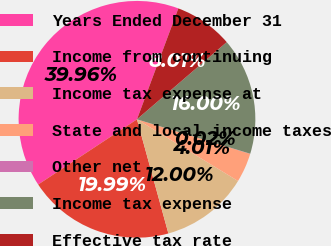Convert chart to OTSL. <chart><loc_0><loc_0><loc_500><loc_500><pie_chart><fcel>Years Ended December 31<fcel>Income from continuing<fcel>Income tax expense at<fcel>State and local income taxes<fcel>Other net<fcel>Income tax expense<fcel>Effective tax rate<nl><fcel>39.96%<fcel>19.99%<fcel>12.0%<fcel>4.01%<fcel>0.02%<fcel>16.0%<fcel>8.01%<nl></chart> 